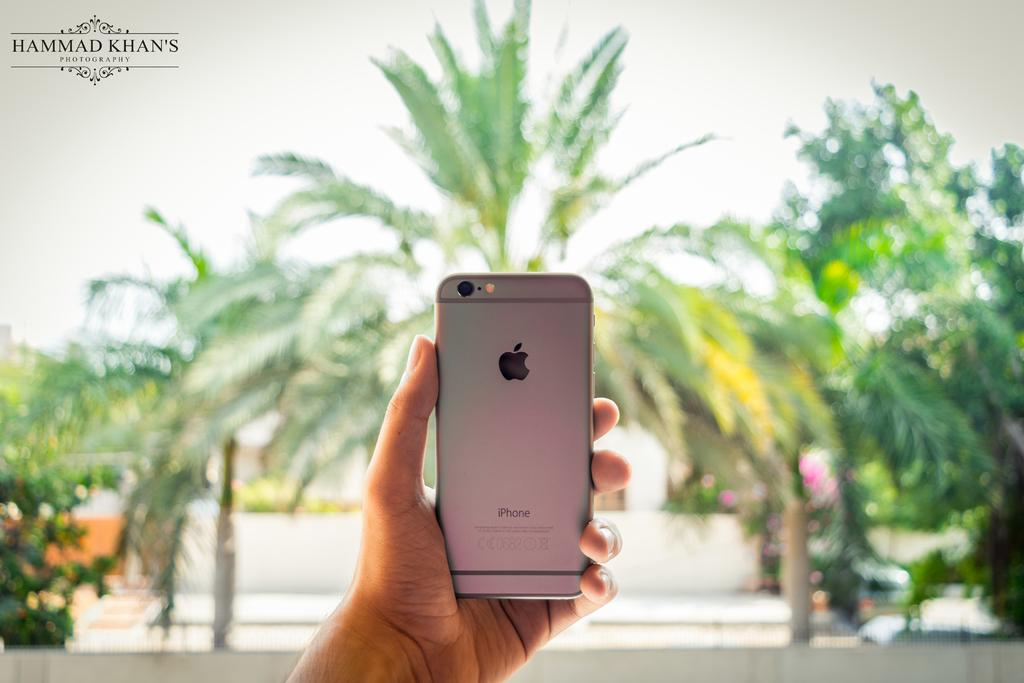What is the person in the image holding? The person is holding a mobile in the image. What type of natural elements can be seen in the image? Trees and plants are visible in the image. What is visible at the top of the image? The sky is visible at the top of the image. Can you describe any additional features of the image? There is a watermark in the left top corner of the image. What type of silverware is being used to cut the quince in the image? There is no silverware or quince present in the image. How is the wax being used in the image? There is no wax present in the image. 